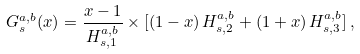<formula> <loc_0><loc_0><loc_500><loc_500>G ^ { a , b } _ { s } ( x ) = \frac { x - 1 } { H ^ { a , b } _ { s , 1 } } \times [ ( 1 - x ) \, H ^ { a , b } _ { s , 2 } + ( 1 + x ) \, H ^ { a , b } _ { s , 3 } ] \, ,</formula> 